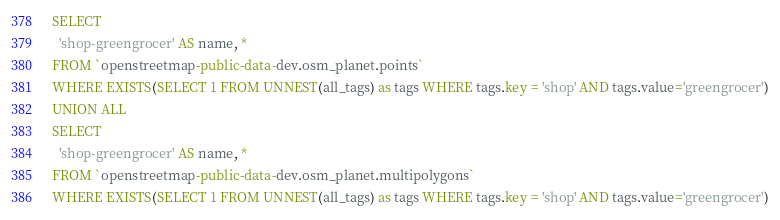<code> <loc_0><loc_0><loc_500><loc_500><_SQL_>SELECT
  'shop-greengrocer' AS name, *
FROM `openstreetmap-public-data-dev.osm_planet.points`
WHERE EXISTS(SELECT 1 FROM UNNEST(all_tags) as tags WHERE tags.key = 'shop' AND tags.value='greengrocer')
UNION ALL
SELECT
  'shop-greengrocer' AS name, *
FROM `openstreetmap-public-data-dev.osm_planet.multipolygons`
WHERE EXISTS(SELECT 1 FROM UNNEST(all_tags) as tags WHERE tags.key = 'shop' AND tags.value='greengrocer')</code> 